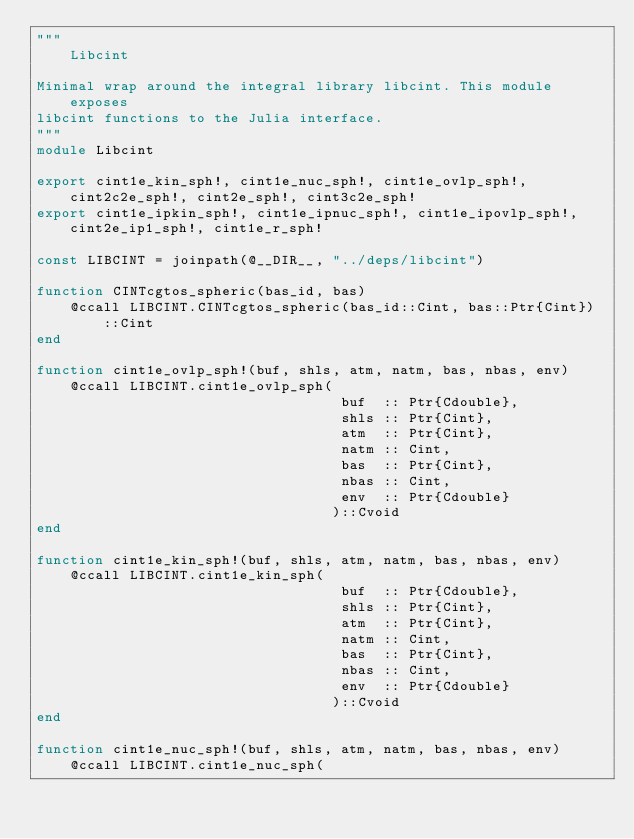<code> <loc_0><loc_0><loc_500><loc_500><_Julia_>"""
    Libcint

Minimal wrap around the integral library libcint. This module exposes
libcint functions to the Julia interface. 
"""
module Libcint

export cint1e_kin_sph!, cint1e_nuc_sph!, cint1e_ovlp_sph!, cint2c2e_sph!, cint2e_sph!, cint3c2e_sph!
export cint1e_ipkin_sph!, cint1e_ipnuc_sph!, cint1e_ipovlp_sph!, cint2e_ip1_sph!, cint1e_r_sph!

const LIBCINT = joinpath(@__DIR__, "../deps/libcint")

function CINTcgtos_spheric(bas_id, bas)
    @ccall LIBCINT.CINTcgtos_spheric(bas_id::Cint, bas::Ptr{Cint})::Cint
end

function cint1e_ovlp_sph!(buf, shls, atm, natm, bas, nbas, env)
    @ccall LIBCINT.cint1e_ovlp_sph(
                                    buf  :: Ptr{Cdouble},
                                    shls :: Ptr{Cint},
                                    atm  :: Ptr{Cint},
                                    natm :: Cint,
                                    bas  :: Ptr{Cint},
                                    nbas :: Cint,
                                    env  :: Ptr{Cdouble}
                                   )::Cvoid
end

function cint1e_kin_sph!(buf, shls, atm, natm, bas, nbas, env)
    @ccall LIBCINT.cint1e_kin_sph(
                                    buf  :: Ptr{Cdouble},
                                    shls :: Ptr{Cint},
                                    atm  :: Ptr{Cint},
                                    natm :: Cint,
                                    bas  :: Ptr{Cint},
                                    nbas :: Cint,
                                    env  :: Ptr{Cdouble}
                                   )::Cvoid
end

function cint1e_nuc_sph!(buf, shls, atm, natm, bas, nbas, env)
    @ccall LIBCINT.cint1e_nuc_sph(</code> 